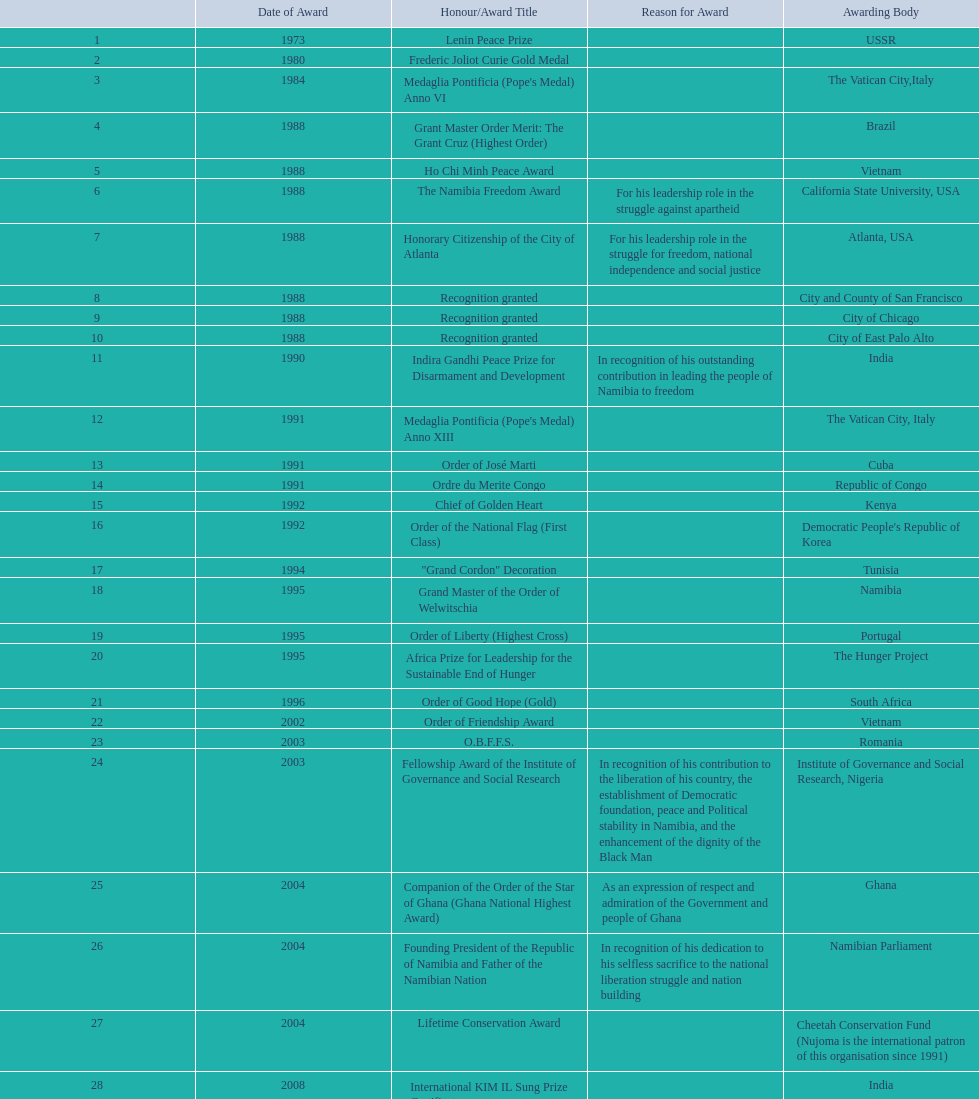What was the name of the honor/award title given after the international kim il sung prize certificate? Sir Seretse Khama SADC Meda. 